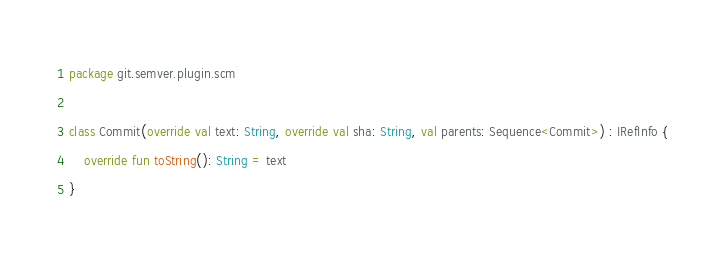<code> <loc_0><loc_0><loc_500><loc_500><_Kotlin_>package git.semver.plugin.scm

class Commit(override val text: String, override val sha: String, val parents: Sequence<Commit>) : IRefInfo {
    override fun toString(): String = text
}

</code> 